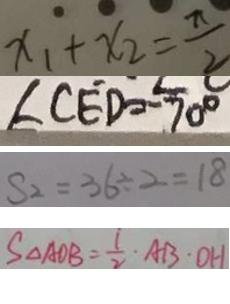Convert formula to latex. <formula><loc_0><loc_0><loc_500><loc_500>x _ { 1 } + x _ { 2 } = \frac { \pi } { 2 } 
 \angle C E D = - 7 0 ^ { \circ } 
 S _ { 2 } = 3 6 \div 2 = 1 8 
 S _ { \Delta A O B } = \frac { 1 } { 2 } \cdot A B \cdot O H</formula> 